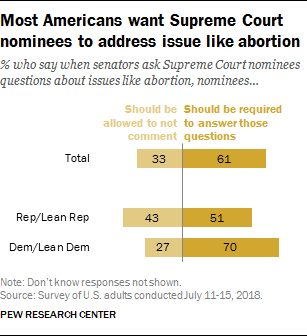Draw attention to some important aspects in this diagram. Orange, which is a color that represents a combination of red and yellow, is often associated with the color of sunset, which can be seen as a symbol of the end of the day and the beginning of night. Dark orange is a shade of orange that is often used to represent a warm and inviting atmosphere, and it can be seen as a symbol of comfort and relaxation. Dark orange is not a specific color in the color wheel, but rather a shade of orange that is created by adding black to the color. The highest value in the list 'What is the highest value in the Should be allowed to not comment? 43..' is 43. 